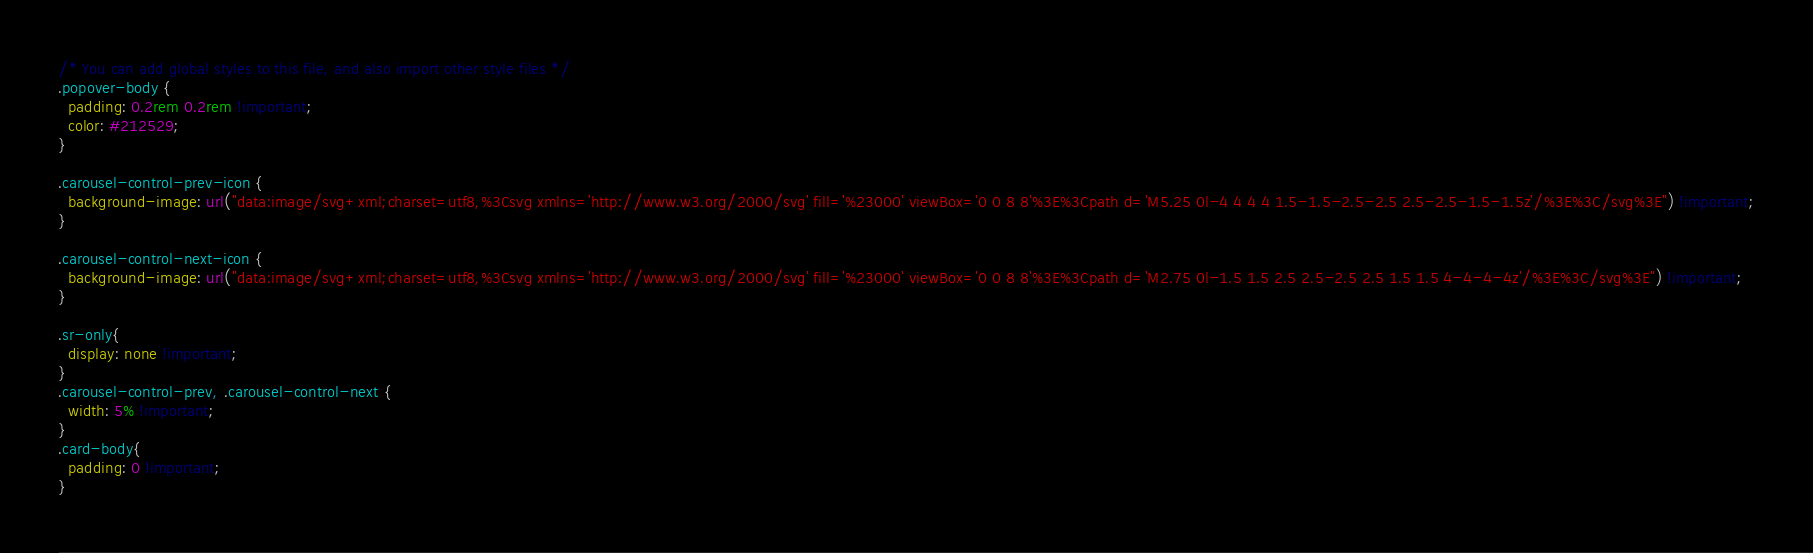<code> <loc_0><loc_0><loc_500><loc_500><_CSS_>/* You can add global styles to this file, and also import other style files */
.popover-body {
  padding: 0.2rem 0.2rem !important;
  color: #212529;
}

.carousel-control-prev-icon {
  background-image: url("data:image/svg+xml;charset=utf8,%3Csvg xmlns='http://www.w3.org/2000/svg' fill='%23000' viewBox='0 0 8 8'%3E%3Cpath d='M5.25 0l-4 4 4 4 1.5-1.5-2.5-2.5 2.5-2.5-1.5-1.5z'/%3E%3C/svg%3E") !important;
}

.carousel-control-next-icon {
  background-image: url("data:image/svg+xml;charset=utf8,%3Csvg xmlns='http://www.w3.org/2000/svg' fill='%23000' viewBox='0 0 8 8'%3E%3Cpath d='M2.75 0l-1.5 1.5 2.5 2.5-2.5 2.5 1.5 1.5 4-4-4-4z'/%3E%3C/svg%3E") !important;
}

.sr-only{
  display: none !important;
}
.carousel-control-prev, .carousel-control-next {
  width: 5% !important;
}
.card-body{
  padding: 0 !important;
}
</code> 